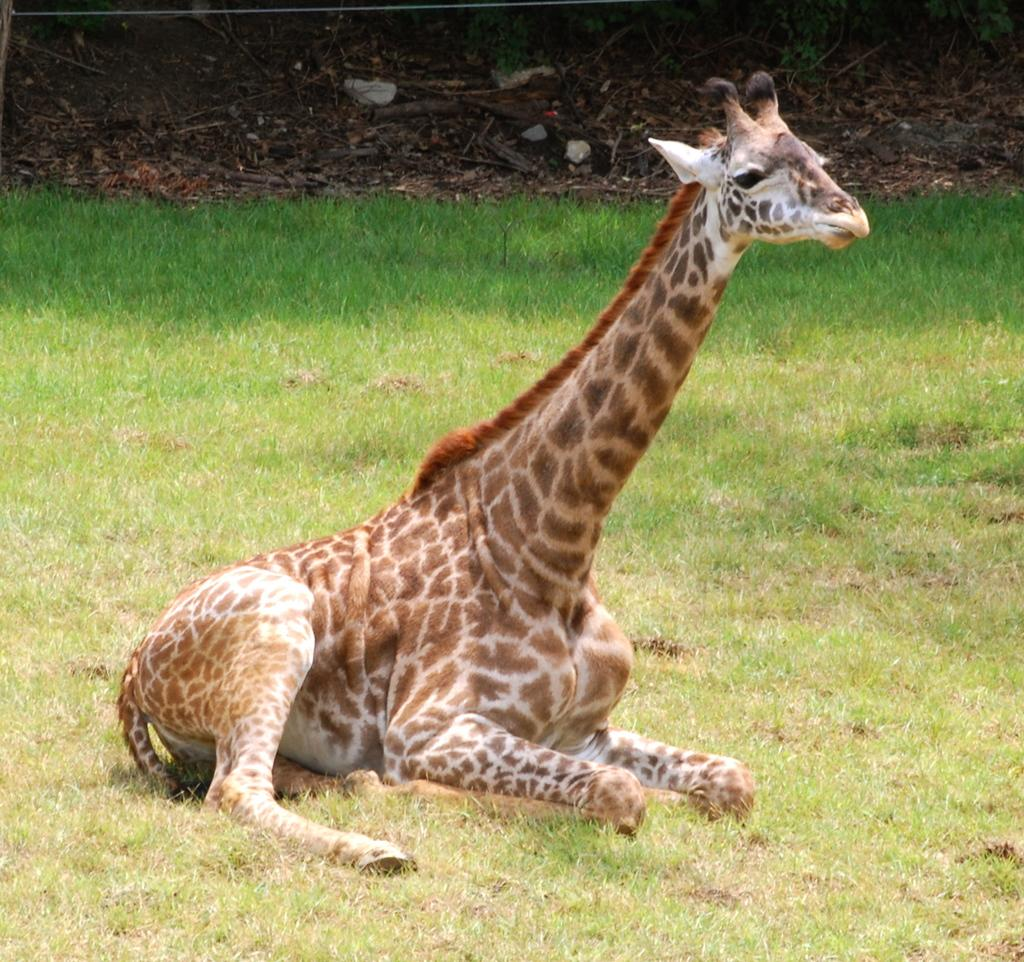What animal is the main subject of the picture? There is a giraffe in the picture. What is the giraffe doing in the image? The giraffe is sitting on the ground. What type of vegetation is at the bottom of the image? There is grass at the bottom of the image. What can be seen in the background of the image? There are sticks and leaves visible in the background of the image. What type of door can be seen in the image? There is no door present in the image; it features a giraffe sitting on the ground with grass and sticks and leaves in the background. 